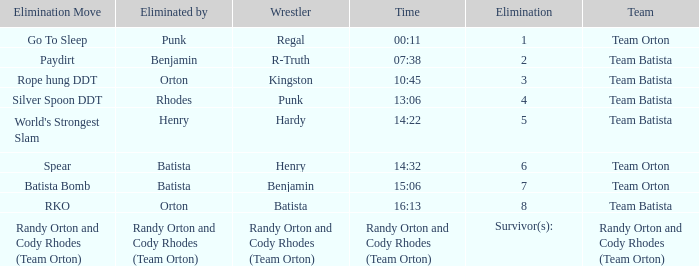Which Wrestler plays for Team Batista which was Elimated by Orton on Elimination 8? Batista. 